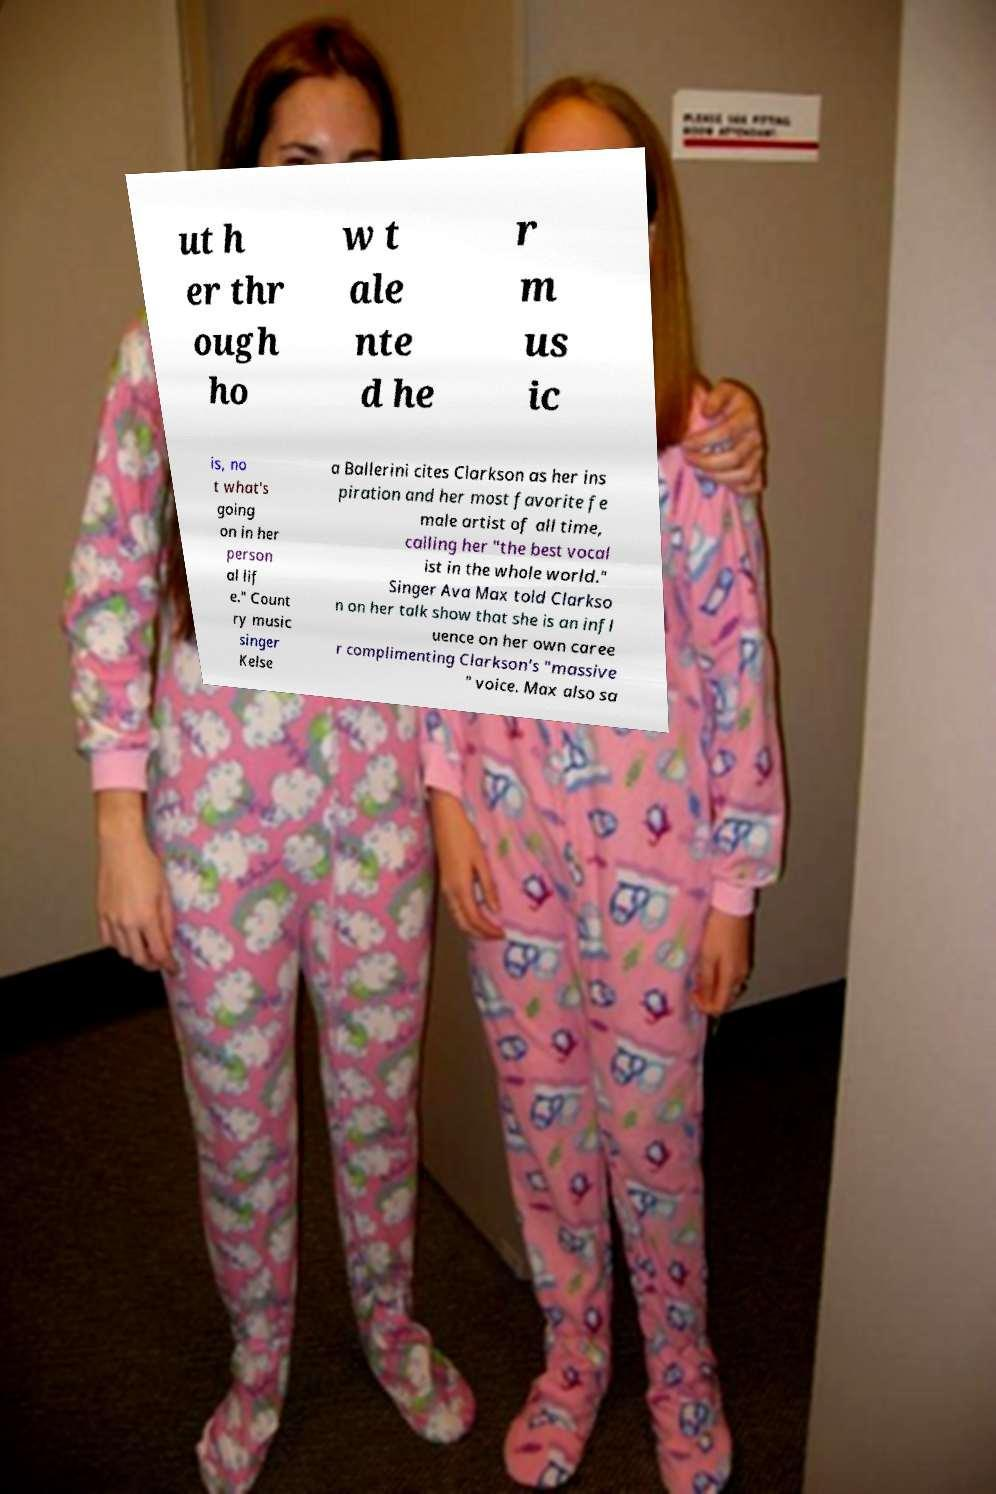Can you read and provide the text displayed in the image?This photo seems to have some interesting text. Can you extract and type it out for me? ut h er thr ough ho w t ale nte d he r m us ic is, no t what's going on in her person al lif e." Count ry music singer Kelse a Ballerini cites Clarkson as her ins piration and her most favorite fe male artist of all time, calling her "the best vocal ist in the whole world." Singer Ava Max told Clarkso n on her talk show that she is an infl uence on her own caree r complimenting Clarkson's "massive " voice. Max also sa 